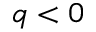<formula> <loc_0><loc_0><loc_500><loc_500>q < 0</formula> 